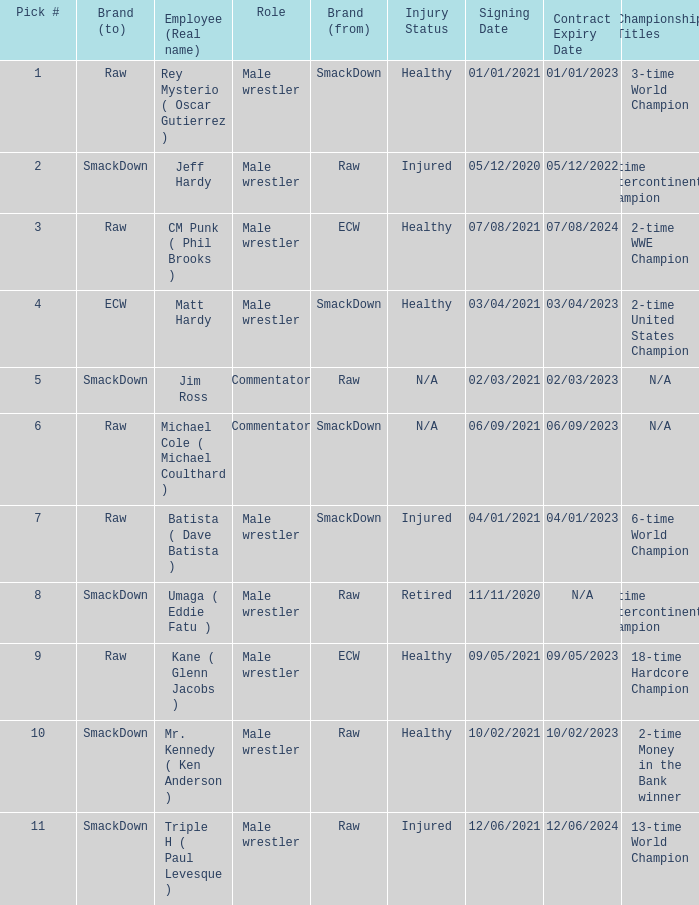What is the real name of the Pick # that is greater than 9? Mr. Kennedy ( Ken Anderson ), Triple H ( Paul Levesque ). 